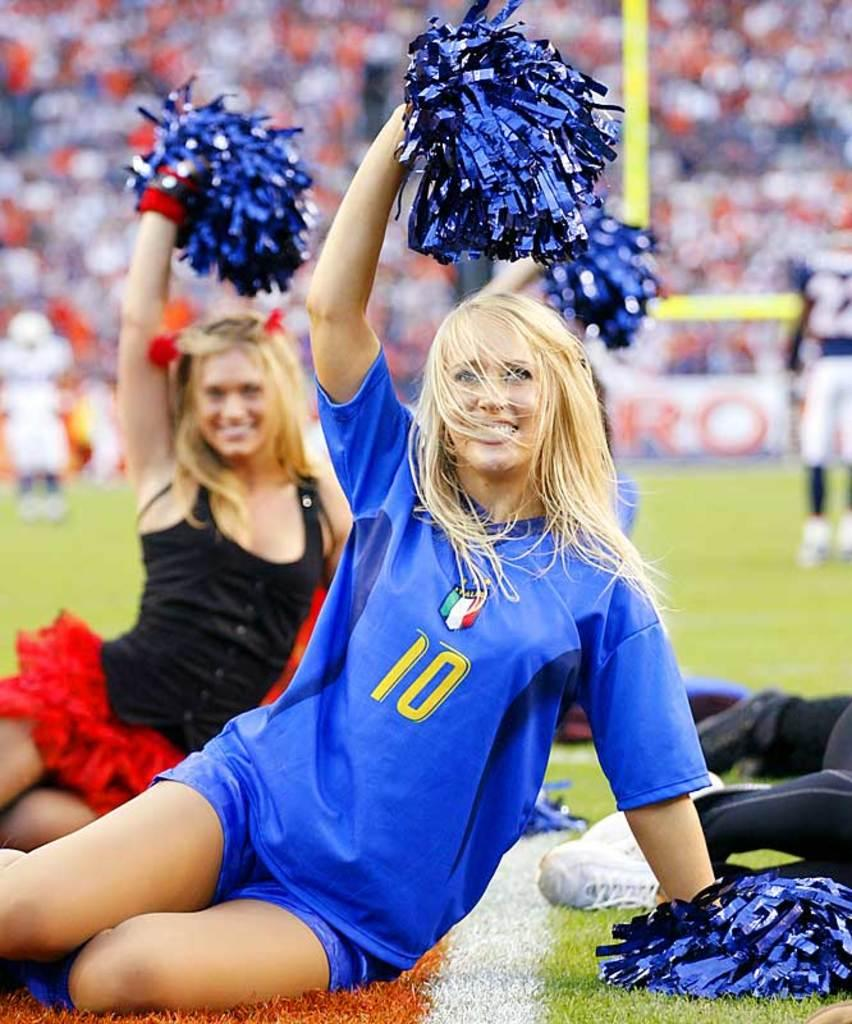<image>
Provide a brief description of the given image. Number 10 is wearing a different outfit than the other cheerleader. 